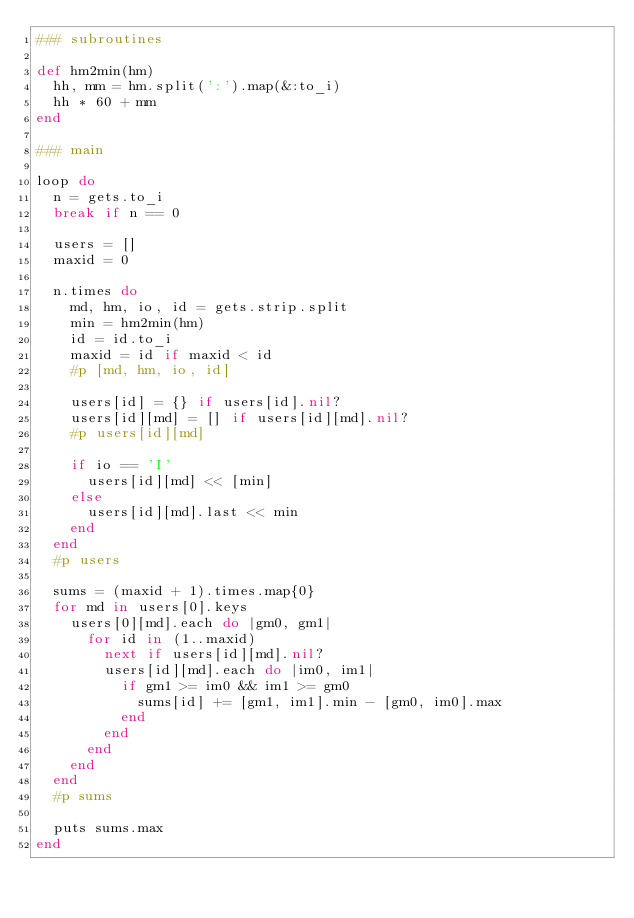Convert code to text. <code><loc_0><loc_0><loc_500><loc_500><_Ruby_>### subroutines

def hm2min(hm)
  hh, mm = hm.split(':').map(&:to_i)
  hh * 60 + mm
end

### main

loop do
  n = gets.to_i
  break if n == 0

  users = []
  maxid = 0
  
  n.times do
    md, hm, io, id = gets.strip.split
    min = hm2min(hm)
    id = id.to_i
    maxid = id if maxid < id
    #p [md, hm, io, id]
    
    users[id] = {} if users[id].nil?
    users[id][md] = [] if users[id][md].nil?
    #p users[id][md]
    
    if io == 'I'
      users[id][md] << [min]
    else
      users[id][md].last << min
    end
  end
  #p users

  sums = (maxid + 1).times.map{0}
  for md in users[0].keys
    users[0][md].each do |gm0, gm1|
      for id in (1..maxid)
        next if users[id][md].nil?
        users[id][md].each do |im0, im1|
          if gm1 >= im0 && im1 >= gm0
            sums[id] += [gm1, im1].min - [gm0, im0].max
          end
        end
      end
    end
  end
  #p sums

  puts sums.max
end</code> 